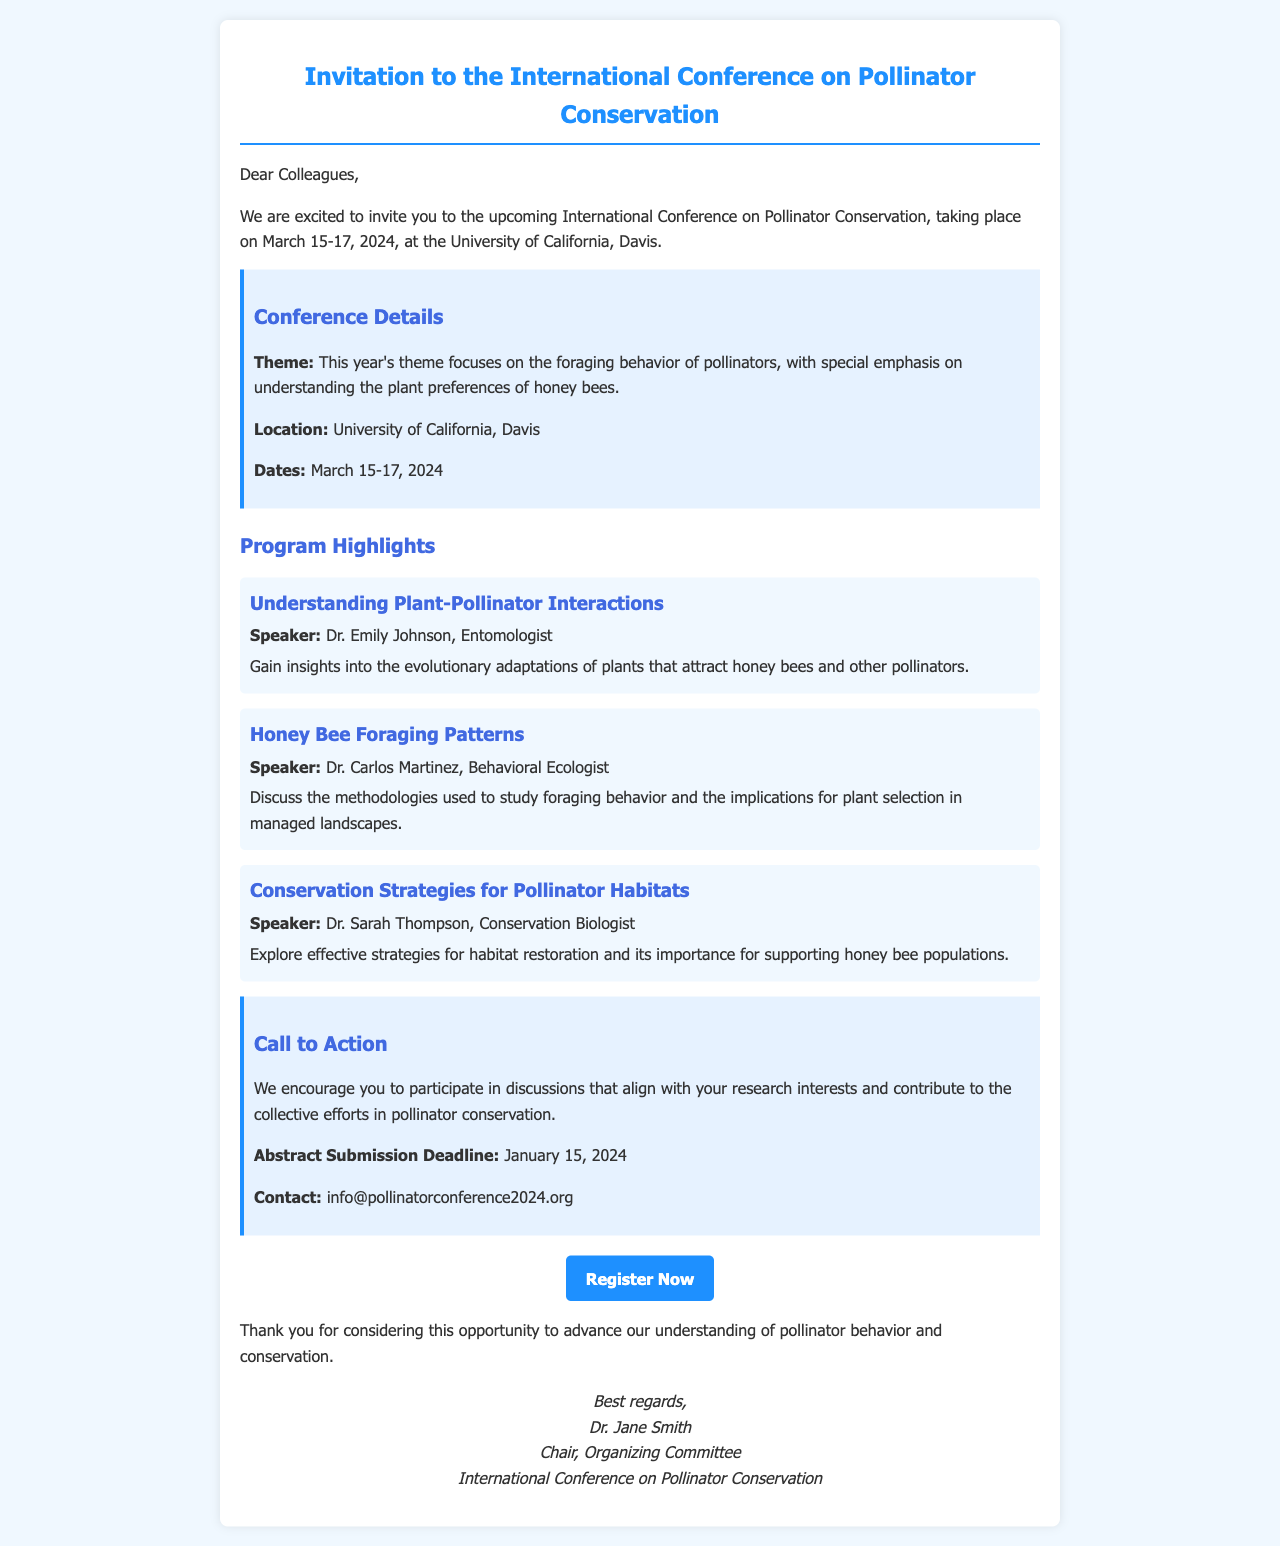What are the dates of the conference? The conference is scheduled for March 15-17, 2024, as stated in the document.
Answer: March 15-17, 2024 Who is the speaker for the session on Honey Bee Foraging Patterns? The document mentions Dr. Carlos Martinez as the speaker for this session.
Answer: Dr. Carlos Martinez What is the theme of this year's conference? The theme is focused on the foraging behavior of pollinators, specifically on plant preferences of honey bees.
Answer: The foraging behavior of pollinators What is the abstract submission deadline? The document states that the abstract submission deadline is January 15, 2024.
Answer: January 15, 2024 Where is the conference taking place? The location of the conference is given as the University of California, Davis.
Answer: University of California, Davis What type of strategies will be discussed by Dr. Sarah Thompson? Dr. Sarah Thompson will explore effective strategies for habitat restoration, which is a conservation strategy.
Answer: Habitat restoration strategies What is the purpose of the "Call to Action" section? The "Call to Action" section encourages participants to engage in discussions relevant to their research interests and contribute to conservation efforts.
Answer: Encourage participation in discussions What kind of insights will Dr. Emily Johnson provide? Dr. Emily Johnson will provide insights into the evolutionary adaptations of plants that attract honey bees and other pollinators.
Answer: Insights into evolutionary adaptations What is the website for registration? The document provides a URL link for registration, specifically stated in the "Register Now" button.
Answer: http://www.pollinatorconference2024.org/register 